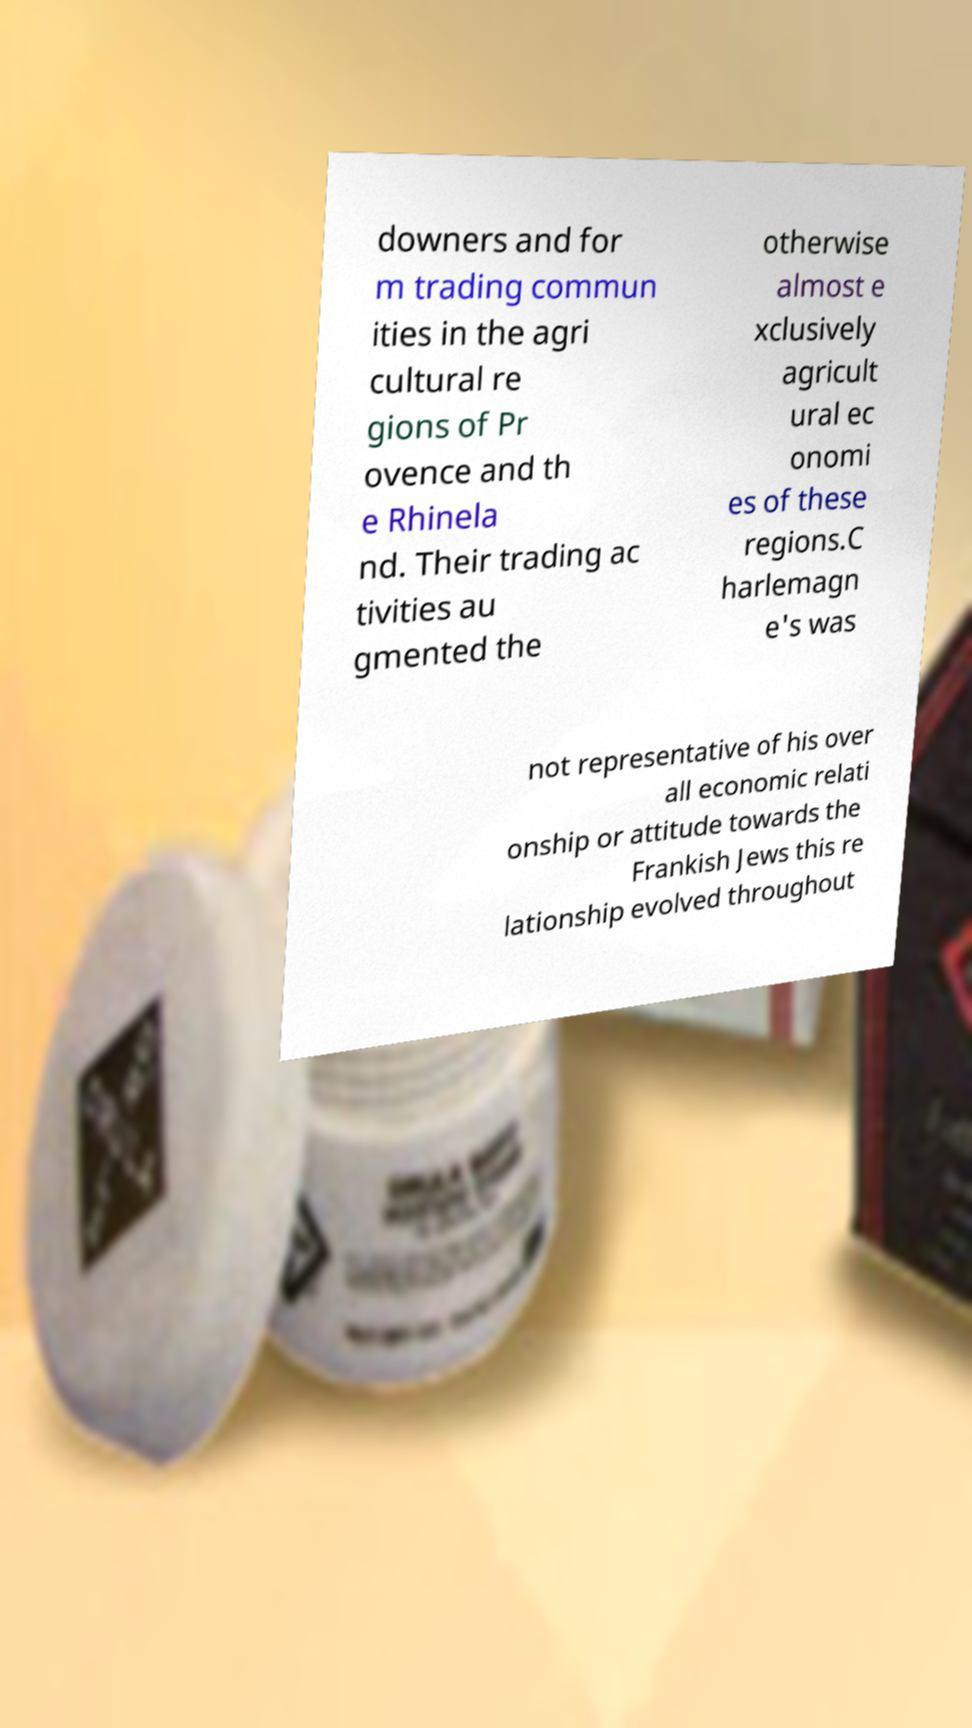What messages or text are displayed in this image? I need them in a readable, typed format. downers and for m trading commun ities in the agri cultural re gions of Pr ovence and th e Rhinela nd. Their trading ac tivities au gmented the otherwise almost e xclusively agricult ural ec onomi es of these regions.C harlemagn e's was not representative of his over all economic relati onship or attitude towards the Frankish Jews this re lationship evolved throughout 